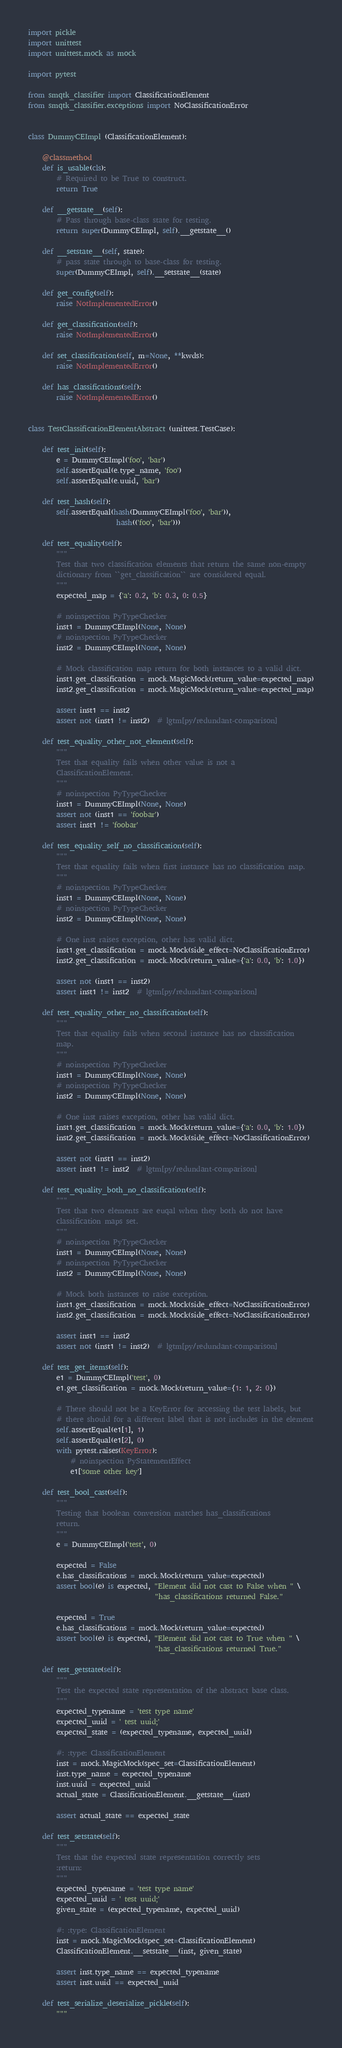<code> <loc_0><loc_0><loc_500><loc_500><_Python_>import pickle
import unittest
import unittest.mock as mock

import pytest

from smqtk_classifier import ClassificationElement
from smqtk_classifier.exceptions import NoClassificationError


class DummyCEImpl (ClassificationElement):

    @classmethod
    def is_usable(cls):
        # Required to be True to construct.
        return True

    def __getstate__(self):
        # Pass through base-class state for testing.
        return super(DummyCEImpl, self).__getstate__()

    def __setstate__(self, state):
        # pass state through to base-class for testing.
        super(DummyCEImpl, self).__setstate__(state)

    def get_config(self):
        raise NotImplementedError()

    def get_classification(self):
        raise NotImplementedError()

    def set_classification(self, m=None, **kwds):
        raise NotImplementedError()

    def has_classifications(self):
        raise NotImplementedError()


class TestClassificationElementAbstract (unittest.TestCase):

    def test_init(self):
        e = DummyCEImpl('foo', 'bar')
        self.assertEqual(e.type_name, 'foo')
        self.assertEqual(e.uuid, 'bar')

    def test_hash(self):
        self.assertEqual(hash(DummyCEImpl('foo', 'bar')),
                         hash(('foo', 'bar')))

    def test_equality(self):
        """
        Test that two classification elements that return the same non-empty
        dictionary from ``get_classification`` are considered equal.
        """
        expected_map = {'a': 0.2, 'b': 0.3, 0: 0.5}

        # noinspection PyTypeChecker
        inst1 = DummyCEImpl(None, None)
        # noinspection PyTypeChecker
        inst2 = DummyCEImpl(None, None)

        # Mock classification map return for both instances to a valid dict.
        inst1.get_classification = mock.MagicMock(return_value=expected_map)
        inst2.get_classification = mock.MagicMock(return_value=expected_map)

        assert inst1 == inst2
        assert not (inst1 != inst2)  # lgtm[py/redundant-comparison]

    def test_equality_other_not_element(self):
        """
        Test that equality fails when other value is not a
        ClassificationElement.
        """
        # noinspection PyTypeChecker
        inst1 = DummyCEImpl(None, None)
        assert not (inst1 == 'foobar')
        assert inst1 != 'foobar'

    def test_equality_self_no_classification(self):
        """
        Test that equality fails when first instance has no classification map.
        """
        # noinspection PyTypeChecker
        inst1 = DummyCEImpl(None, None)
        # noinspection PyTypeChecker
        inst2 = DummyCEImpl(None, None)

        # One inst raises exception, other has valid dict.
        inst1.get_classification = mock.Mock(side_effect=NoClassificationError)
        inst2.get_classification = mock.Mock(return_value={'a': 0.0, 'b': 1.0})

        assert not (inst1 == inst2)
        assert inst1 != inst2  # lgtm[py/redundant-comparison]

    def test_equality_other_no_classification(self):
        """
        Test that equality fails when second instance has no classification
        map.
        """
        # noinspection PyTypeChecker
        inst1 = DummyCEImpl(None, None)
        # noinspection PyTypeChecker
        inst2 = DummyCEImpl(None, None)

        # One inst raises exception, other has valid dict.
        inst1.get_classification = mock.Mock(return_value={'a': 0.0, 'b': 1.0})
        inst2.get_classification = mock.Mock(side_effect=NoClassificationError)

        assert not (inst1 == inst2)
        assert inst1 != inst2  # lgtm[py/redundant-comparison]

    def test_equality_both_no_classification(self):
        """
        Test that two elements are euqal when they both do not have
        classification maps set.
        """
        # noinspection PyTypeChecker
        inst1 = DummyCEImpl(None, None)
        # noinspection PyTypeChecker
        inst2 = DummyCEImpl(None, None)

        # Mock both instances to raise exception.
        inst1.get_classification = mock.Mock(side_effect=NoClassificationError)
        inst2.get_classification = mock.Mock(side_effect=NoClassificationError)

        assert inst1 == inst2
        assert not (inst1 != inst2)  # lgtm[py/redundant-comparison]

    def test_get_items(self):
        e1 = DummyCEImpl('test', 0)
        e1.get_classification = mock.Mock(return_value={1: 1, 2: 0})

        # There should not be a KeyError for accessing the test labels, but
        # there should for a different label that is not includes in the element
        self.assertEqual(e1[1], 1)
        self.assertEqual(e1[2], 0)
        with pytest.raises(KeyError):
            # noinspection PyStatementEffect
            e1['some other key']

    def test_bool_cast(self):
        """
        Testing that boolean conversion matches has_classifications
        return.
        """
        e = DummyCEImpl('test', 0)

        expected = False
        e.has_classifications = mock.Mock(return_value=expected)
        assert bool(e) is expected, "Element did not cast to False when " \
                                    "has_classifications returned False."

        expected = True
        e.has_classifications = mock.Mock(return_value=expected)
        assert bool(e) is expected, "Element did not cast to True when " \
                                    "has_classifications returned True."

    def test_getstate(self):
        """
        Test the expected state representation of the abstract base class.
        """
        expected_typename = 'test type name'
        expected_uuid = ' test uuid;'
        expected_state = (expected_typename, expected_uuid)

        #: :type: ClassificationElement
        inst = mock.MagicMock(spec_set=ClassificationElement)
        inst.type_name = expected_typename
        inst.uuid = expected_uuid
        actual_state = ClassificationElement.__getstate__(inst)

        assert actual_state == expected_state

    def test_setstate(self):
        """
        Test that the expected state representation correctly sets
        :return:
        """
        expected_typename = 'test type name'
        expected_uuid = ' test uuid;'
        given_state = (expected_typename, expected_uuid)

        #: :type: ClassificationElement
        inst = mock.MagicMock(spec_set=ClassificationElement)
        ClassificationElement.__setstate__(inst, given_state)

        assert inst.type_name == expected_typename
        assert inst.uuid == expected_uuid

    def test_serialize_deserialize_pickle(self):
        """</code> 